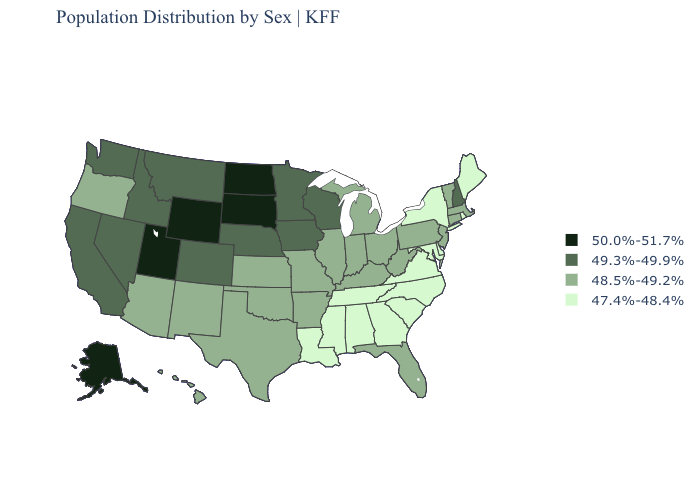Name the states that have a value in the range 50.0%-51.7%?
Be succinct. Alaska, North Dakota, South Dakota, Utah, Wyoming. What is the value of Indiana?
Quick response, please. 48.5%-49.2%. Does California have the same value as Montana?
Keep it brief. Yes. Does North Dakota have the highest value in the USA?
Short answer required. Yes. Which states have the highest value in the USA?
Concise answer only. Alaska, North Dakota, South Dakota, Utah, Wyoming. Which states hav the highest value in the MidWest?
Give a very brief answer. North Dakota, South Dakota. What is the lowest value in states that border Kentucky?
Give a very brief answer. 47.4%-48.4%. Is the legend a continuous bar?
Short answer required. No. Name the states that have a value in the range 49.3%-49.9%?
Quick response, please. California, Colorado, Idaho, Iowa, Minnesota, Montana, Nebraska, Nevada, New Hampshire, Washington, Wisconsin. Which states have the lowest value in the USA?
Keep it brief. Alabama, Delaware, Georgia, Louisiana, Maine, Maryland, Mississippi, New York, North Carolina, Rhode Island, South Carolina, Tennessee, Virginia. Which states have the lowest value in the USA?
Keep it brief. Alabama, Delaware, Georgia, Louisiana, Maine, Maryland, Mississippi, New York, North Carolina, Rhode Island, South Carolina, Tennessee, Virginia. What is the lowest value in states that border California?
Short answer required. 48.5%-49.2%. Which states have the lowest value in the MidWest?
Keep it brief. Illinois, Indiana, Kansas, Michigan, Missouri, Ohio. What is the highest value in the USA?
Write a very short answer. 50.0%-51.7%. Name the states that have a value in the range 50.0%-51.7%?
Write a very short answer. Alaska, North Dakota, South Dakota, Utah, Wyoming. 